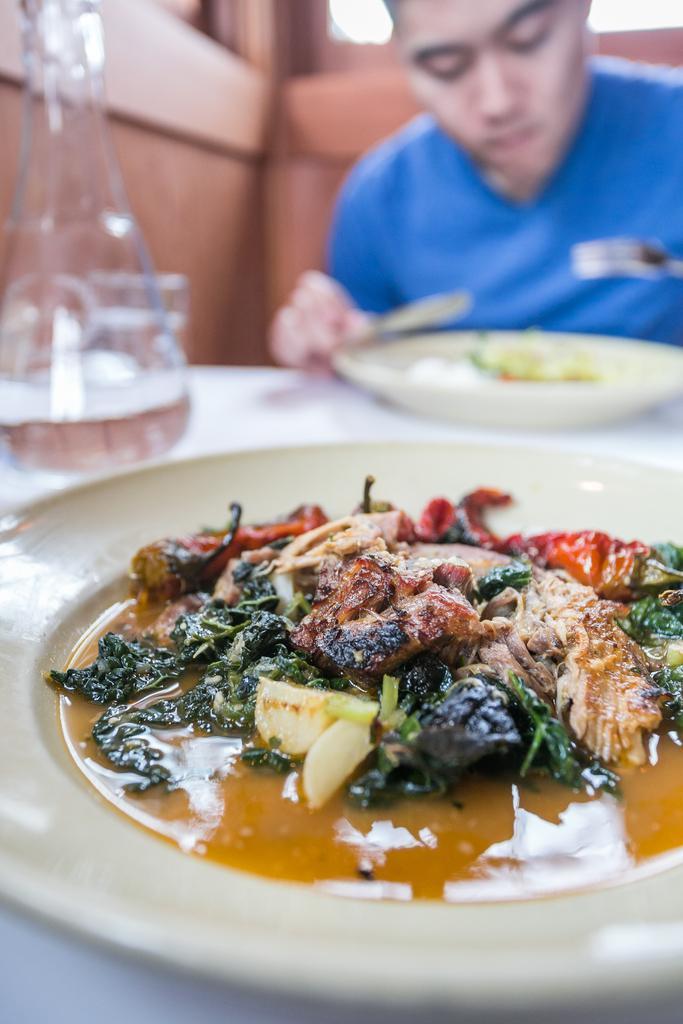In one or two sentences, can you explain what this image depicts? In front of the image there is a food item on a plate, beside the plate there is a jar, glass and another plate with food items, in front of that plate there is a person holding knife and fork in his hand, behind him there is a wooden wall. 